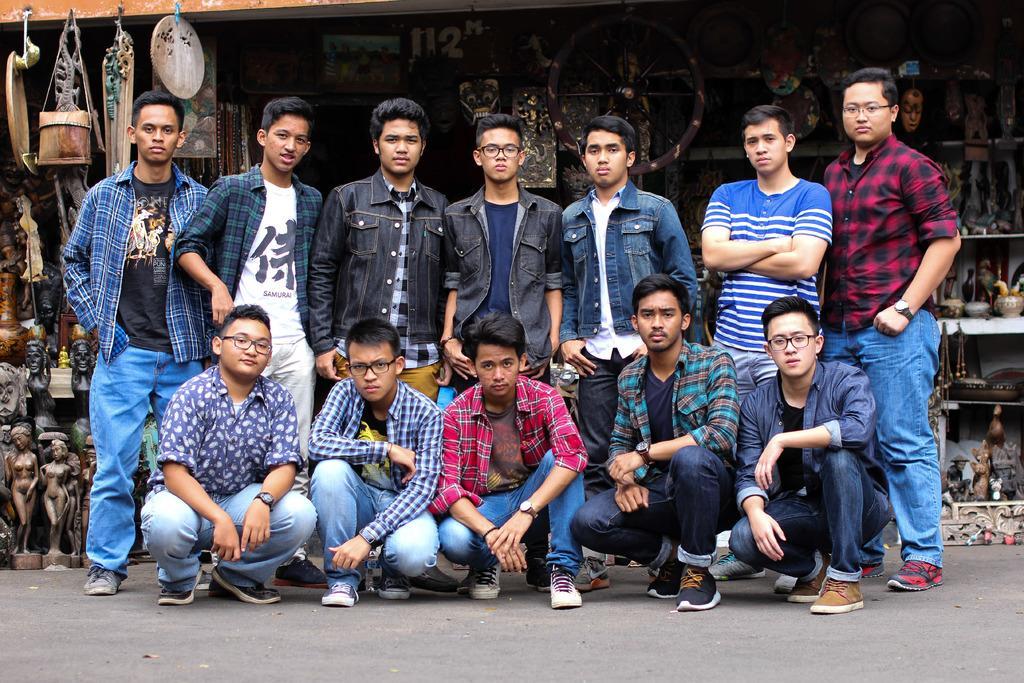In one or two sentences, can you explain what this image depicts? In the center of the image we can see boys standing and some of them are sitting. At the bottom there is a road. In the background we can see a store of statues and sculptures. 